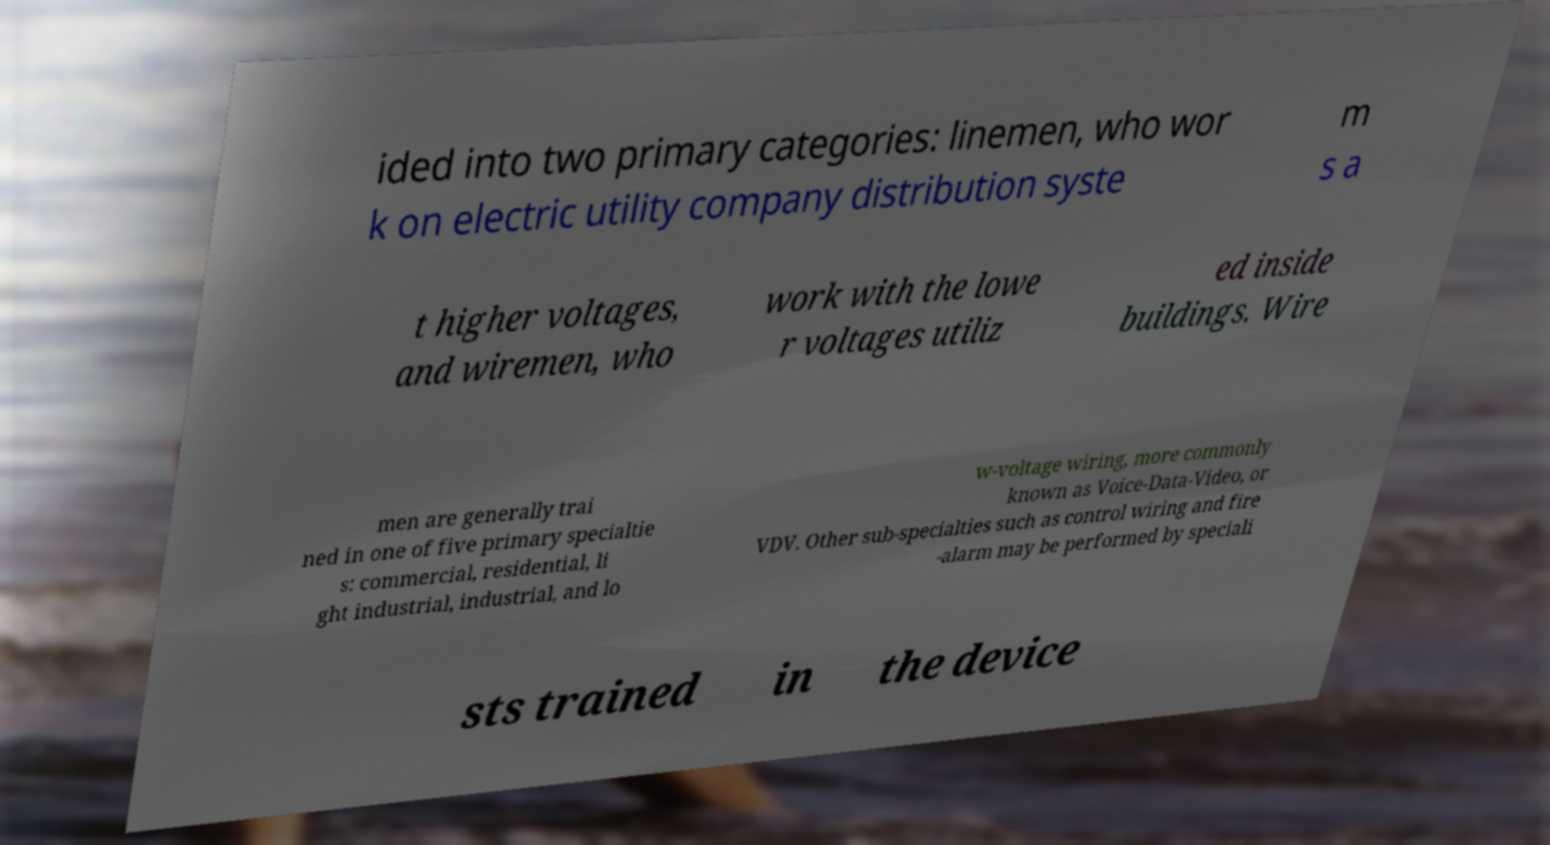What messages or text are displayed in this image? I need them in a readable, typed format. ided into two primary categories: linemen, who wor k on electric utility company distribution syste m s a t higher voltages, and wiremen, who work with the lowe r voltages utiliz ed inside buildings. Wire men are generally trai ned in one of five primary specialtie s: commercial, residential, li ght industrial, industrial, and lo w-voltage wiring, more commonly known as Voice-Data-Video, or VDV. Other sub-specialties such as control wiring and fire -alarm may be performed by speciali sts trained in the device 